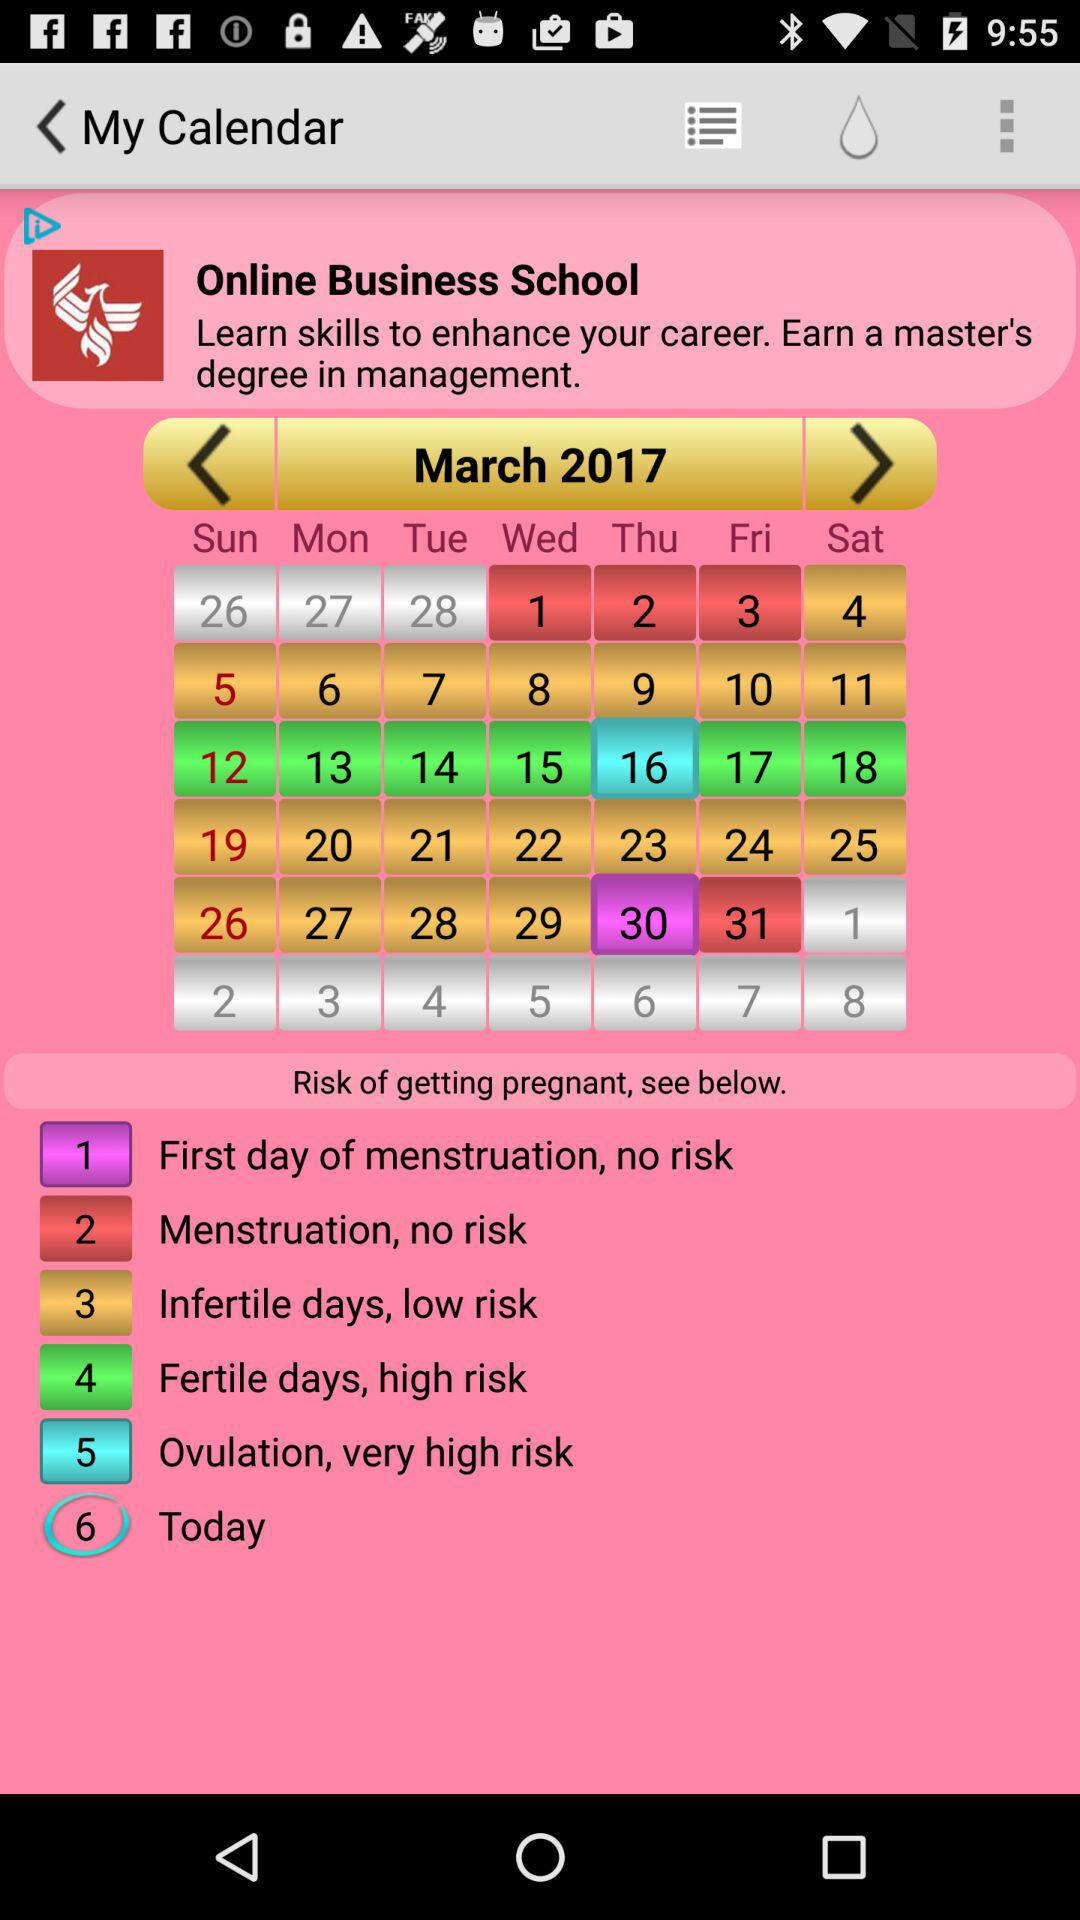Which are the fertile days? The fertile days are from March 12th, 2017 to March 18th, 2017. 